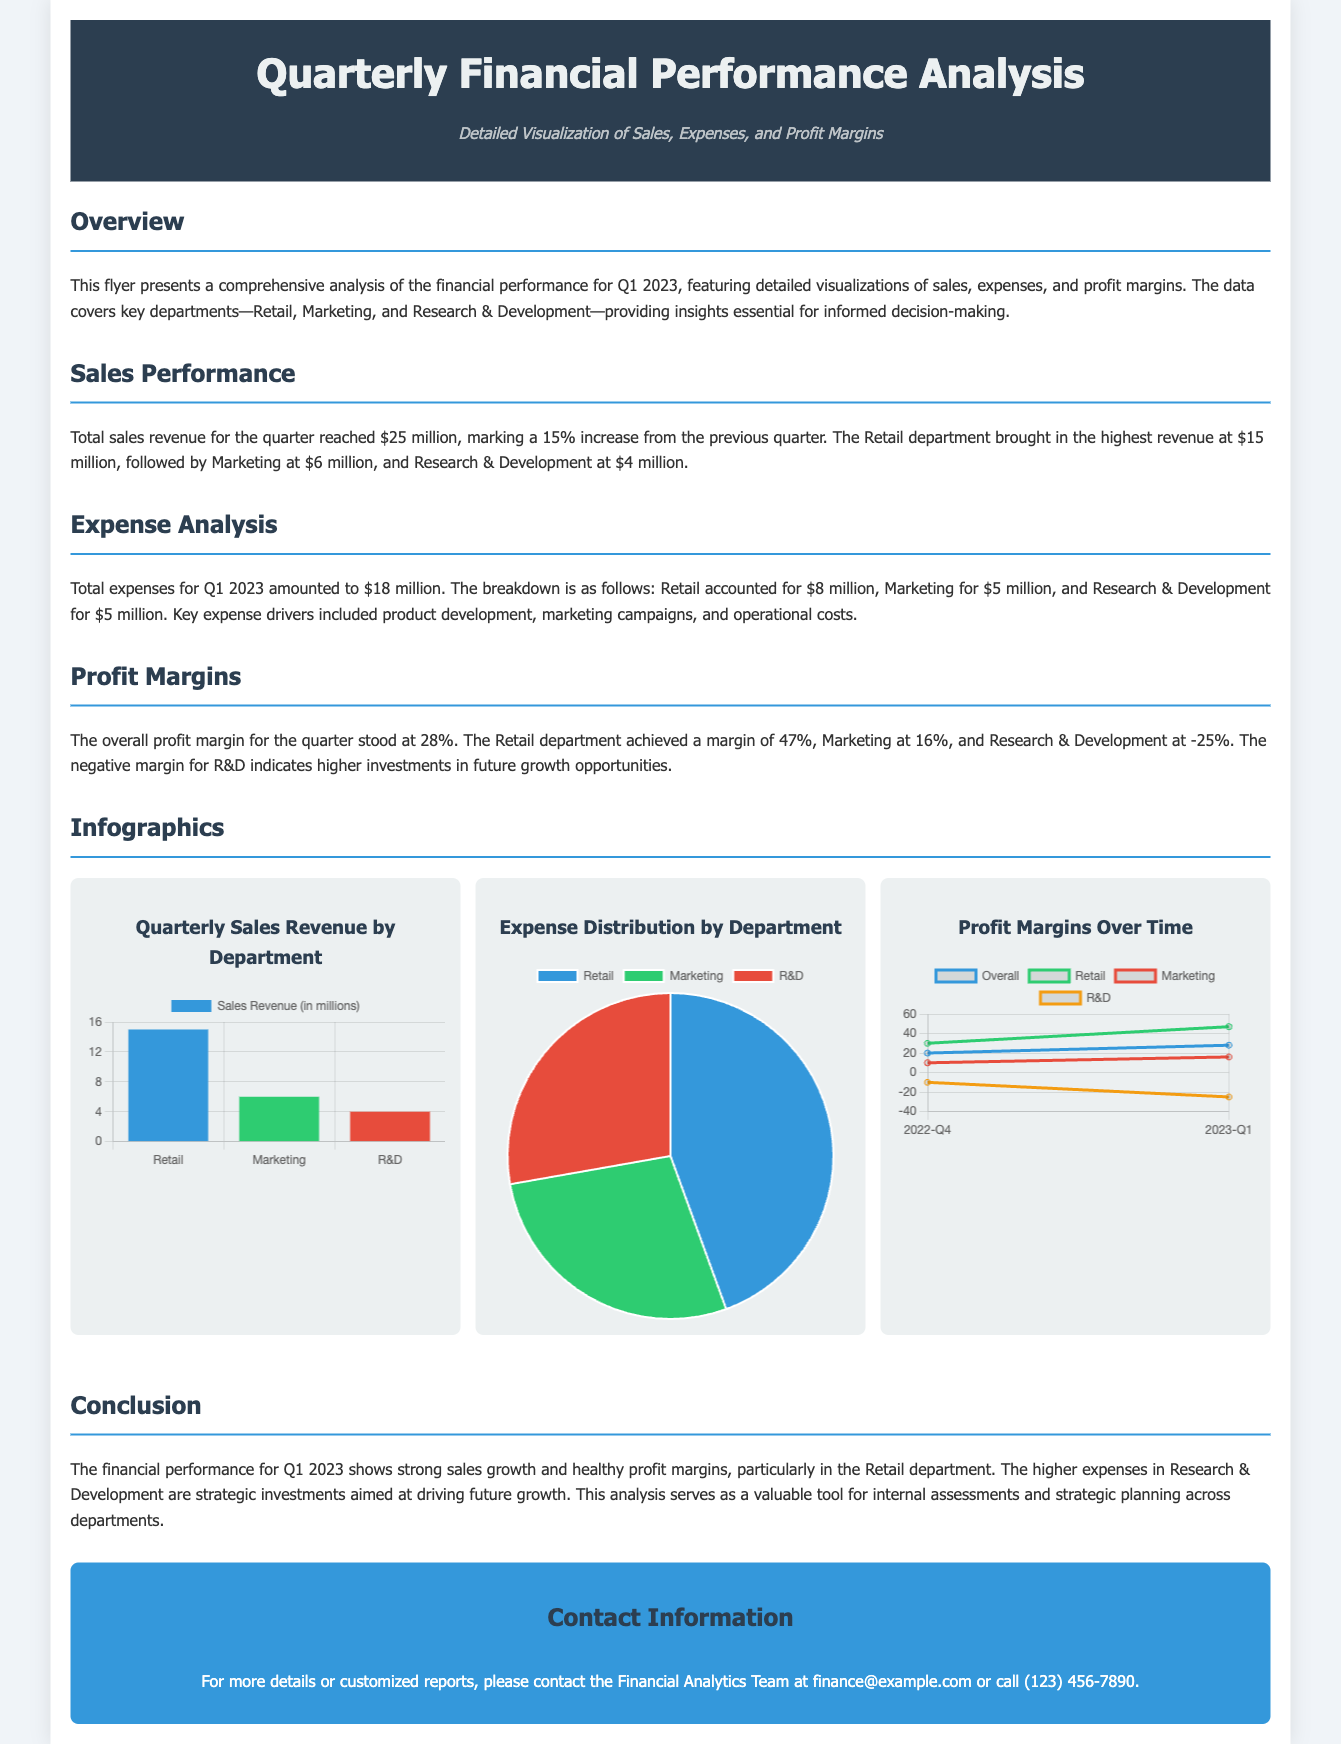What is the total sales revenue for Q1 2023? The total sales revenue for the quarter is given as $25 million.
Answer: $25 million Which department generated the highest revenue? The document states that the Retail department brought in the highest revenue at $15 million.
Answer: Retail What were the total expenses for Q1 2023? The total expenses for Q1 2023 are listed as $18 million in the document.
Answer: $18 million What is the overall profit margin for the quarter? The document indicates that the overall profit margin for the quarter is 28%.
Answer: 28% Which department has a negative profit margin? According to the document, the Research & Development department has a negative profit margin of -25%.
Answer: Research & Development What is the sales revenue generated by the Marketing department? The document specifies that the Marketing department generated $6 million in sales revenue.
Answer: $6 million What type of chart shows the expense distribution by department? The document describes the Expense Distribution as being represented by a pie chart.
Answer: Pie chart How much did the Retail department spend on expenses? The Retail department's expenses are stated as $8 million in the document.
Answer: $8 million What is the subtitle of the flyer? The subtitle of the flyer is "Detailed Visualization of Sales, Expenses, and Profit Margins."
Answer: Detailed Visualization of Sales, Expenses, and Profit Margins 